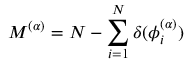Convert formula to latex. <formula><loc_0><loc_0><loc_500><loc_500>{ M ^ { ( \alpha ) } = N - \sum _ { i = 1 } ^ { N } \delta ( \phi _ { i } ^ { ( \alpha ) } ) }</formula> 